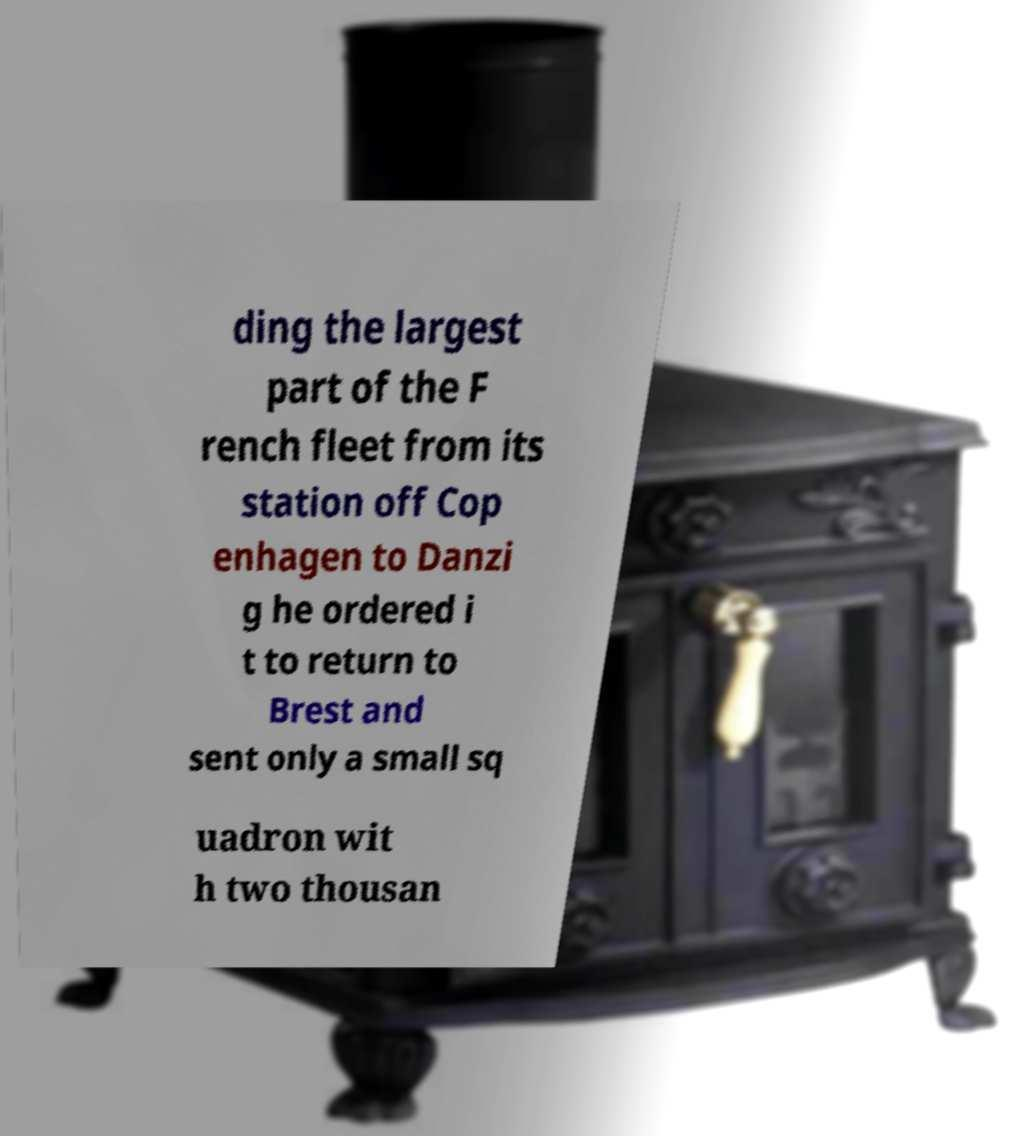Can you read and provide the text displayed in the image?This photo seems to have some interesting text. Can you extract and type it out for me? ding the largest part of the F rench fleet from its station off Cop enhagen to Danzi g he ordered i t to return to Brest and sent only a small sq uadron wit h two thousan 